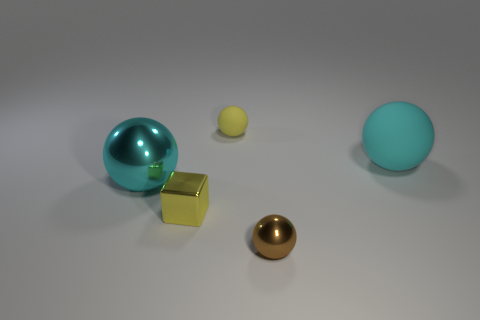What number of other objects are there of the same size as the cyan matte object?
Your response must be concise. 1. How big is the cyan sphere behind the cyan object left of the brown ball?
Provide a succinct answer. Large. What number of large objects are either purple matte objects or brown objects?
Make the answer very short. 0. There is a cyan thing on the right side of the object left of the small yellow object in front of the cyan matte thing; what size is it?
Ensure brevity in your answer.  Large. Are there any other things that have the same color as the big shiny ball?
Make the answer very short. Yes. There is a large cyan thing behind the cyan sphere that is in front of the rubber thing that is to the right of the brown metallic sphere; what is it made of?
Provide a short and direct response. Rubber. Is the big rubber object the same shape as the brown thing?
Give a very brief answer. Yes. How many balls are both left of the small matte object and in front of the tiny yellow shiny cube?
Give a very brief answer. 0. The large thing that is on the right side of the ball that is on the left side of the block is what color?
Your answer should be very brief. Cyan. Are there the same number of matte objects in front of the yellow ball and big rubber spheres?
Offer a very short reply. Yes. 